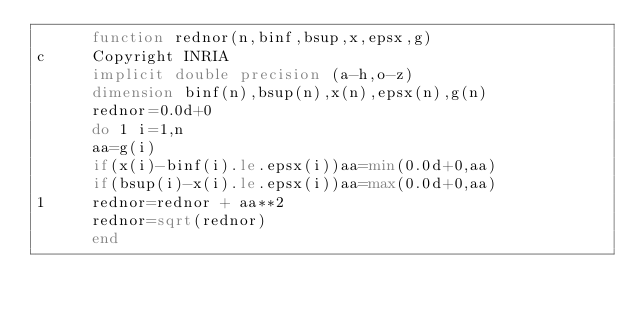Convert code to text. <code><loc_0><loc_0><loc_500><loc_500><_FORTRAN_>      function rednor(n,binf,bsup,x,epsx,g)
c     Copyright INRIA
      implicit double precision (a-h,o-z)
      dimension binf(n),bsup(n),x(n),epsx(n),g(n)
      rednor=0.0d+0
      do 1 i=1,n
      aa=g(i)
      if(x(i)-binf(i).le.epsx(i))aa=min(0.0d+0,aa)
      if(bsup(i)-x(i).le.epsx(i))aa=max(0.0d+0,aa)
1     rednor=rednor + aa**2
      rednor=sqrt(rednor)
      end
</code> 